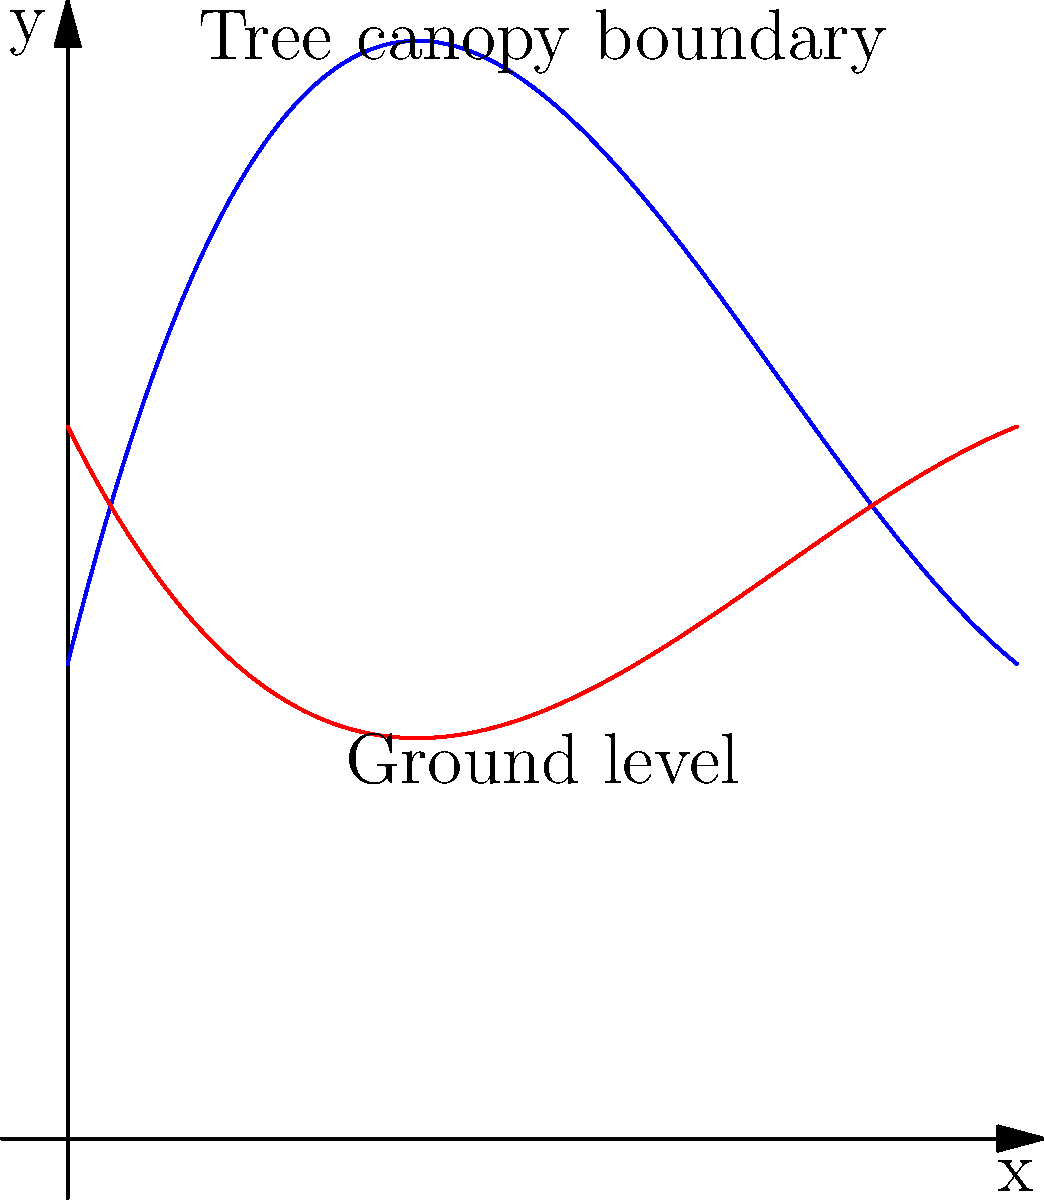The blue curve represents the upper boundary of an irregular tree canopy, while the red curve represents the ground level. Both curves can be modeled by cubic polynomials. The upper boundary is given by $f(x) = 0.2x^3 - 1.8x^2 + 4x + 2$, and the ground level is given by $g(x) = -0.1x^3 + 0.9x^2 - 2x + 3$, where $x$ is measured in meters. Calculate the area of the tree canopy cross-section between $x = 0$ and $x = 4$ meters. To find the area of the tree canopy cross-section, we need to calculate the area between the two curves from $x = 0$ to $x = 4$. This can be done using definite integration.

1. The area between two curves is given by the integral of the difference between the upper and lower functions:

   $A = \int_{a}^{b} [f(x) - g(x)] dx$

2. In this case, we have:
   $f(x) = 0.2x^3 - 1.8x^2 + 4x + 2$
   $g(x) = -0.1x^3 + 0.9x^2 - 2x + 3$
   $a = 0$ and $b = 4$

3. Let's subtract $g(x)$ from $f(x)$:
   $f(x) - g(x) = (0.2x^3 - 1.8x^2 + 4x + 2) - (-0.1x^3 + 0.9x^2 - 2x + 3)$
                = $0.3x^3 - 2.7x^2 + 6x - 1$

4. Now we integrate this difference from 0 to 4:
   $A = \int_{0}^{4} (0.3x^3 - 2.7x^2 + 6x - 1) dx$

5. Integrating term by term:
   $A = [0.075x^4 - 0.9x^3 + 3x^2 - x]_{0}^{4}$

6. Evaluating at the limits:
   $A = (0.075 * 4^4 - 0.9 * 4^3 + 3 * 4^2 - 4) - (0.075 * 0^4 - 0.9 * 0^3 + 3 * 0^2 - 0)$
   $A = (76.8 - 57.6 + 48 - 4) - 0$
   $A = 63.2$

Therefore, the area of the tree canopy cross-section is 63.2 square meters.
Answer: 63.2 m² 